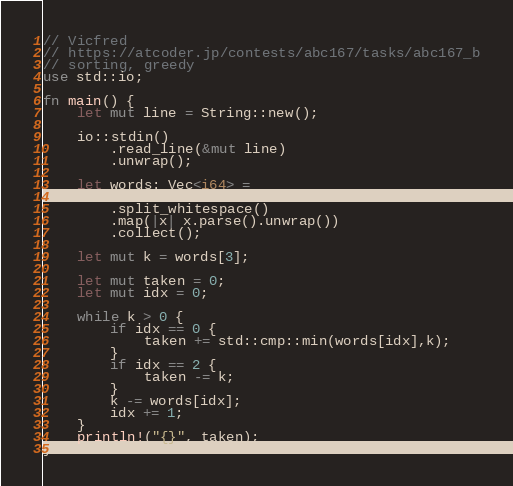Convert code to text. <code><loc_0><loc_0><loc_500><loc_500><_Rust_>// Vicfred
// https://atcoder.jp/contests/abc167/tasks/abc167_b
// sorting, greedy
use std::io;

fn main() {
    let mut line = String::new();

    io::stdin()
        .read_line(&mut line)
        .unwrap();

    let words: Vec<i64> =
        line
        .split_whitespace()
        .map(|x| x.parse().unwrap())
        .collect();

    let mut k = words[3];

    let mut taken = 0;
    let mut idx = 0;

    while k > 0 {
        if idx == 0 {
            taken += std::cmp::min(words[idx],k);
        }
        if idx == 2 {
            taken -= k;
        }
        k -= words[idx];
        idx += 1;
    }
    println!("{}", taken);
}

</code> 